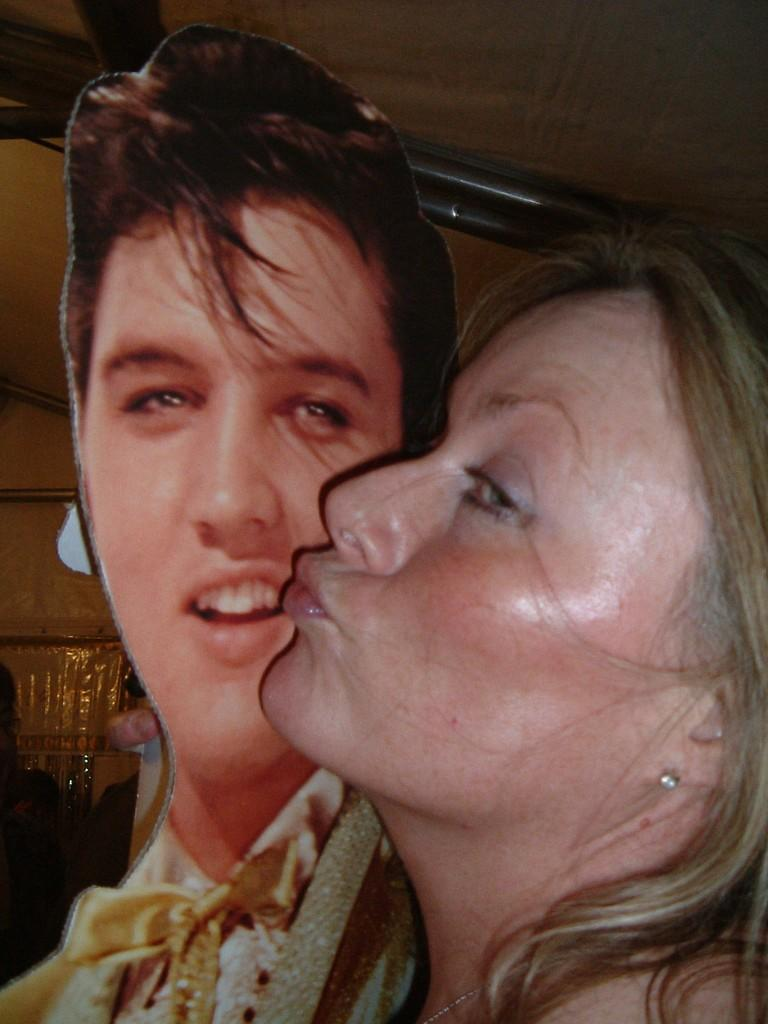Who is present in the image? There is a woman in the image. What is the woman holding in the image? The woman is holding a photo of a person. What can be seen in the background of the image? There are poles in the background of the image. Where is the lunchroom located in the image? There is no mention of a lunchroom in the image; it only features a woman holding a photo and poles in the background. What type of yarn is being used to create the poles in the background? The poles in the background are not made of yarn; they are likely made of metal or another material. 